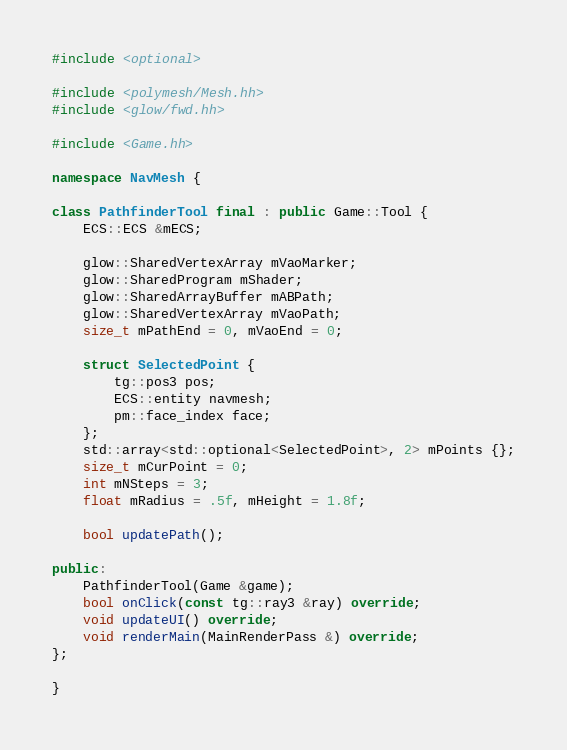Convert code to text. <code><loc_0><loc_0><loc_500><loc_500><_C++_>#include <optional>

#include <polymesh/Mesh.hh>
#include <glow/fwd.hh>

#include <Game.hh>

namespace NavMesh {

class PathfinderTool final : public Game::Tool {
    ECS::ECS &mECS;

    glow::SharedVertexArray mVaoMarker;
    glow::SharedProgram mShader;
    glow::SharedArrayBuffer mABPath;
    glow::SharedVertexArray mVaoPath;
    size_t mPathEnd = 0, mVaoEnd = 0;

    struct SelectedPoint {
        tg::pos3 pos;
        ECS::entity navmesh;
        pm::face_index face;
    };
    std::array<std::optional<SelectedPoint>, 2> mPoints {};
    size_t mCurPoint = 0;
    int mNSteps = 3;
    float mRadius = .5f, mHeight = 1.8f;

    bool updatePath();

public:
    PathfinderTool(Game &game);
    bool onClick(const tg::ray3 &ray) override;
    void updateUI() override;
    void renderMain(MainRenderPass &) override;
};

}
</code> 